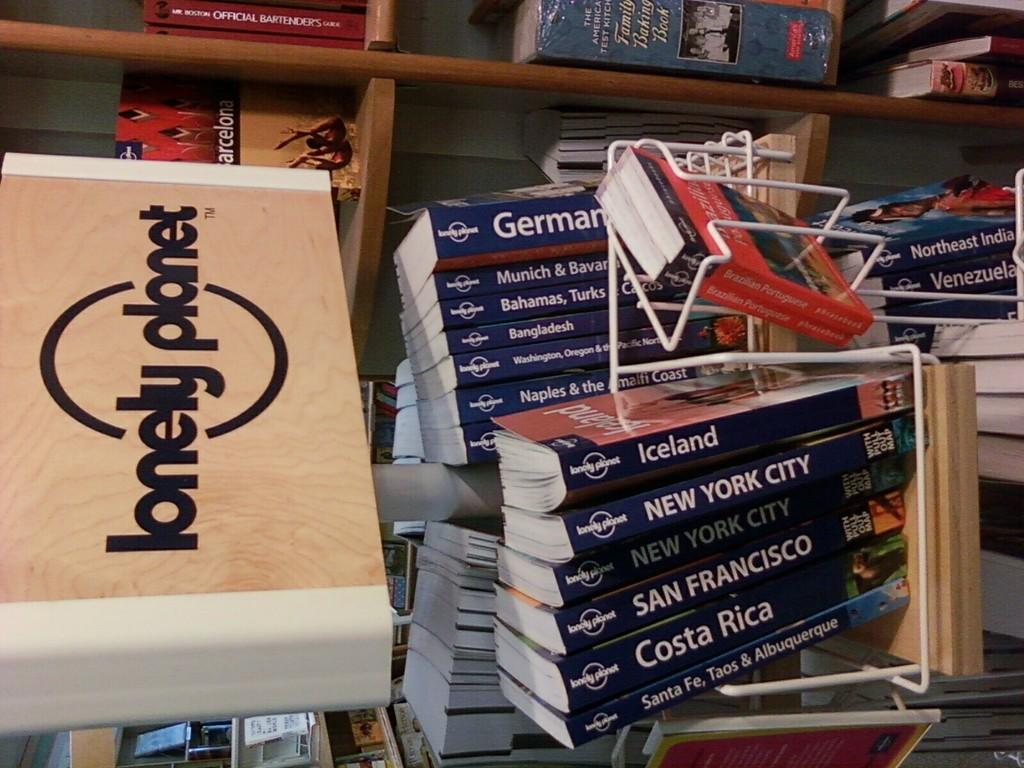<image>
Describe the image concisely. A tourist guide for Iceland and Costa Rica are displayed with other city guides 